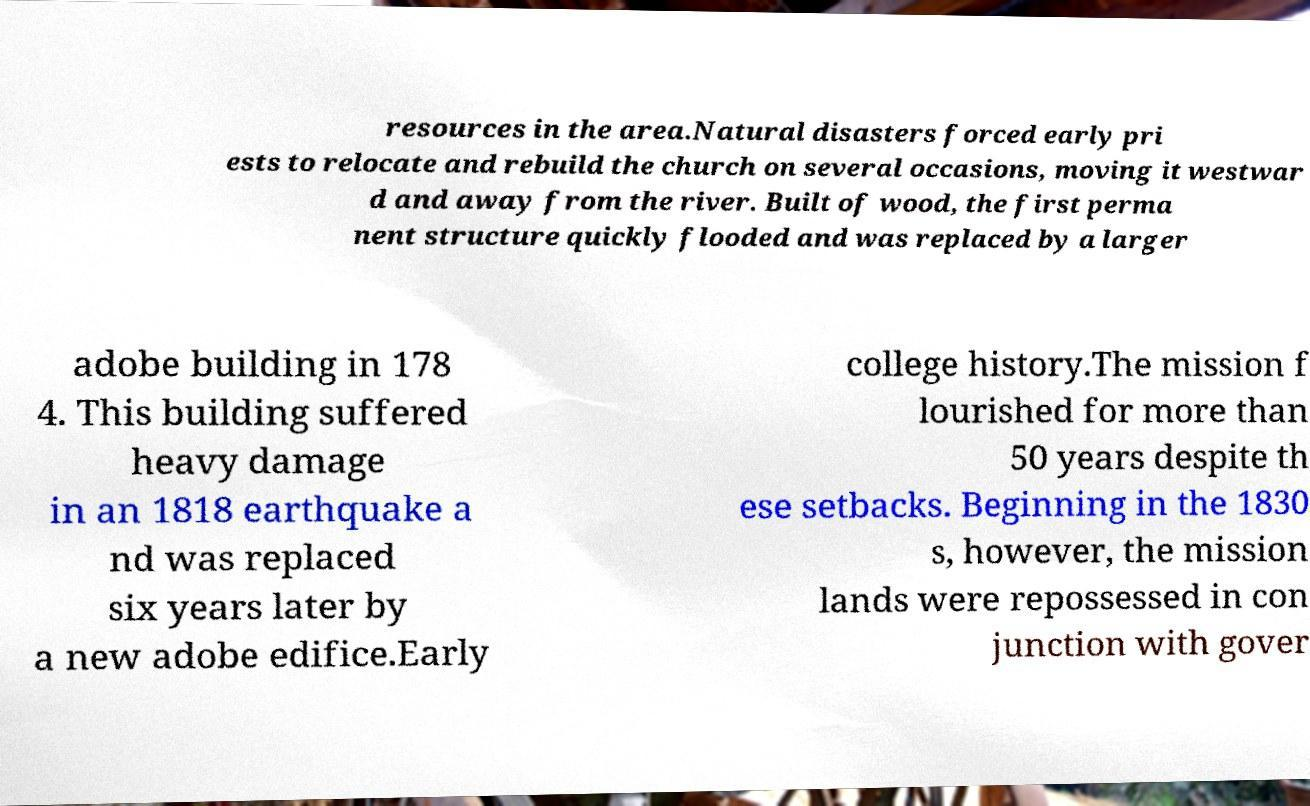Can you accurately transcribe the text from the provided image for me? resources in the area.Natural disasters forced early pri ests to relocate and rebuild the church on several occasions, moving it westwar d and away from the river. Built of wood, the first perma nent structure quickly flooded and was replaced by a larger adobe building in 178 4. This building suffered heavy damage in an 1818 earthquake a nd was replaced six years later by a new adobe edifice.Early college history.The mission f lourished for more than 50 years despite th ese setbacks. Beginning in the 1830 s, however, the mission lands were repossessed in con junction with gover 